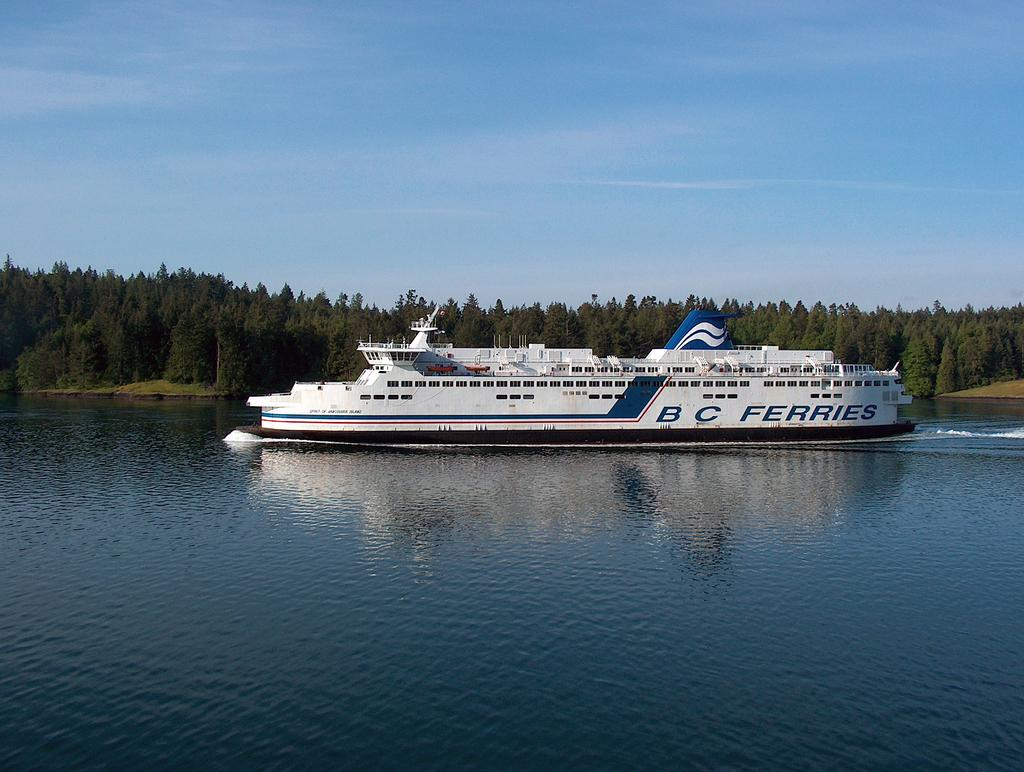What type of vehicle is in the image? There is a ferry in the image. What color is the ferry? The ferry is white in color. Where is the ferry located? The ferry is on the water. What can be seen in the background of the image? There are trees and a clear sky in the background of the image. What type of bed can be seen on the ferry in the image? There is no bed present on the ferry in the image. 